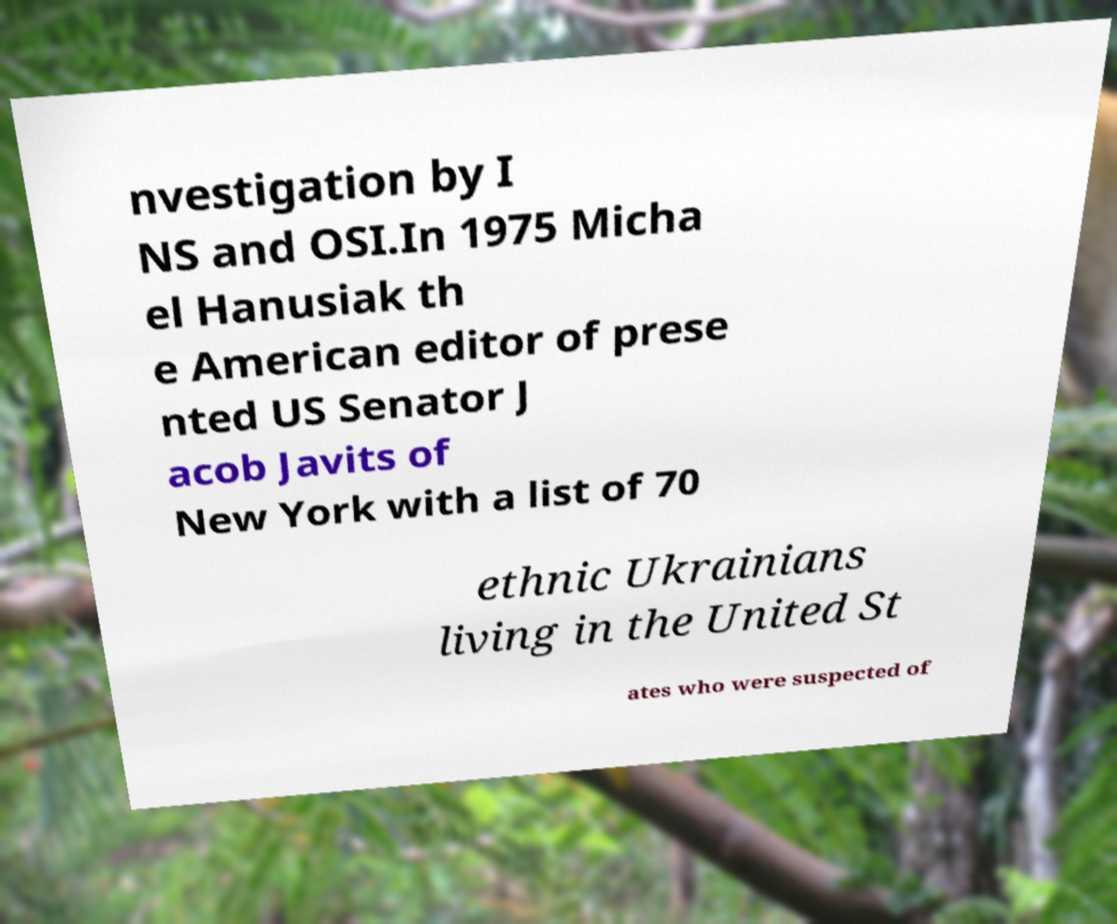What messages or text are displayed in this image? I need them in a readable, typed format. nvestigation by I NS and OSI.In 1975 Micha el Hanusiak th e American editor of prese nted US Senator J acob Javits of New York with a list of 70 ethnic Ukrainians living in the United St ates who were suspected of 